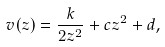<formula> <loc_0><loc_0><loc_500><loc_500>v ( z ) = \frac { k } { 2 z ^ { 2 } } + c z ^ { 2 } + d ,</formula> 